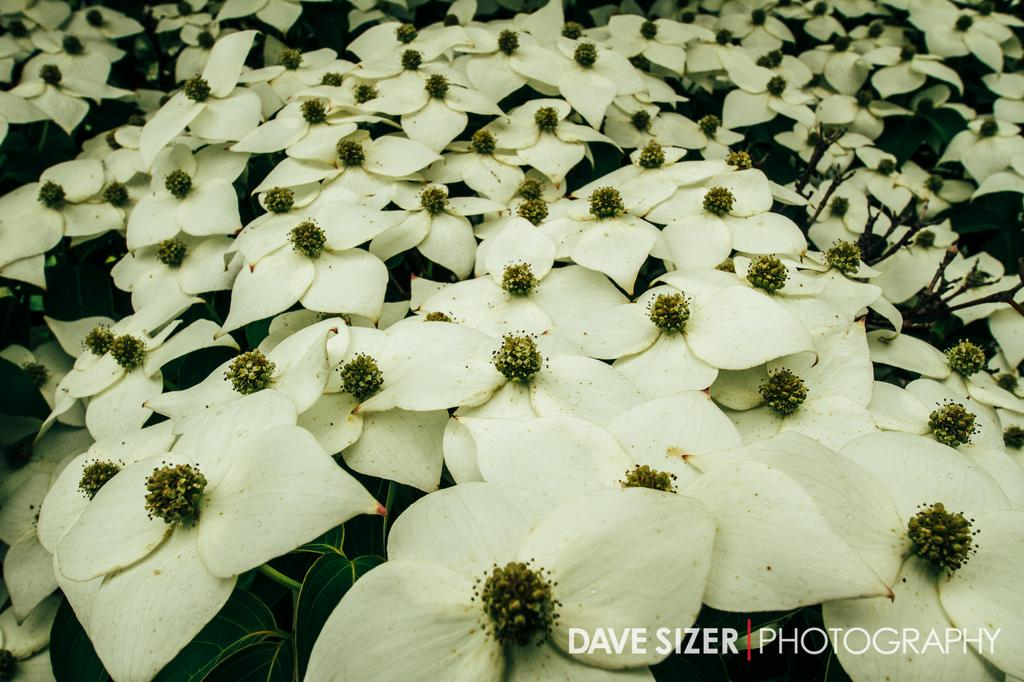What can be seen in the foreground of the image? There are many flowers and plants in the foreground of the image. What is located at the bottom of the image? There is text at the bottom of the image. What type of bird can be seen flying in the image? There is no bird present in the image; it features many flowers and plants in the foreground and text at the bottom. 